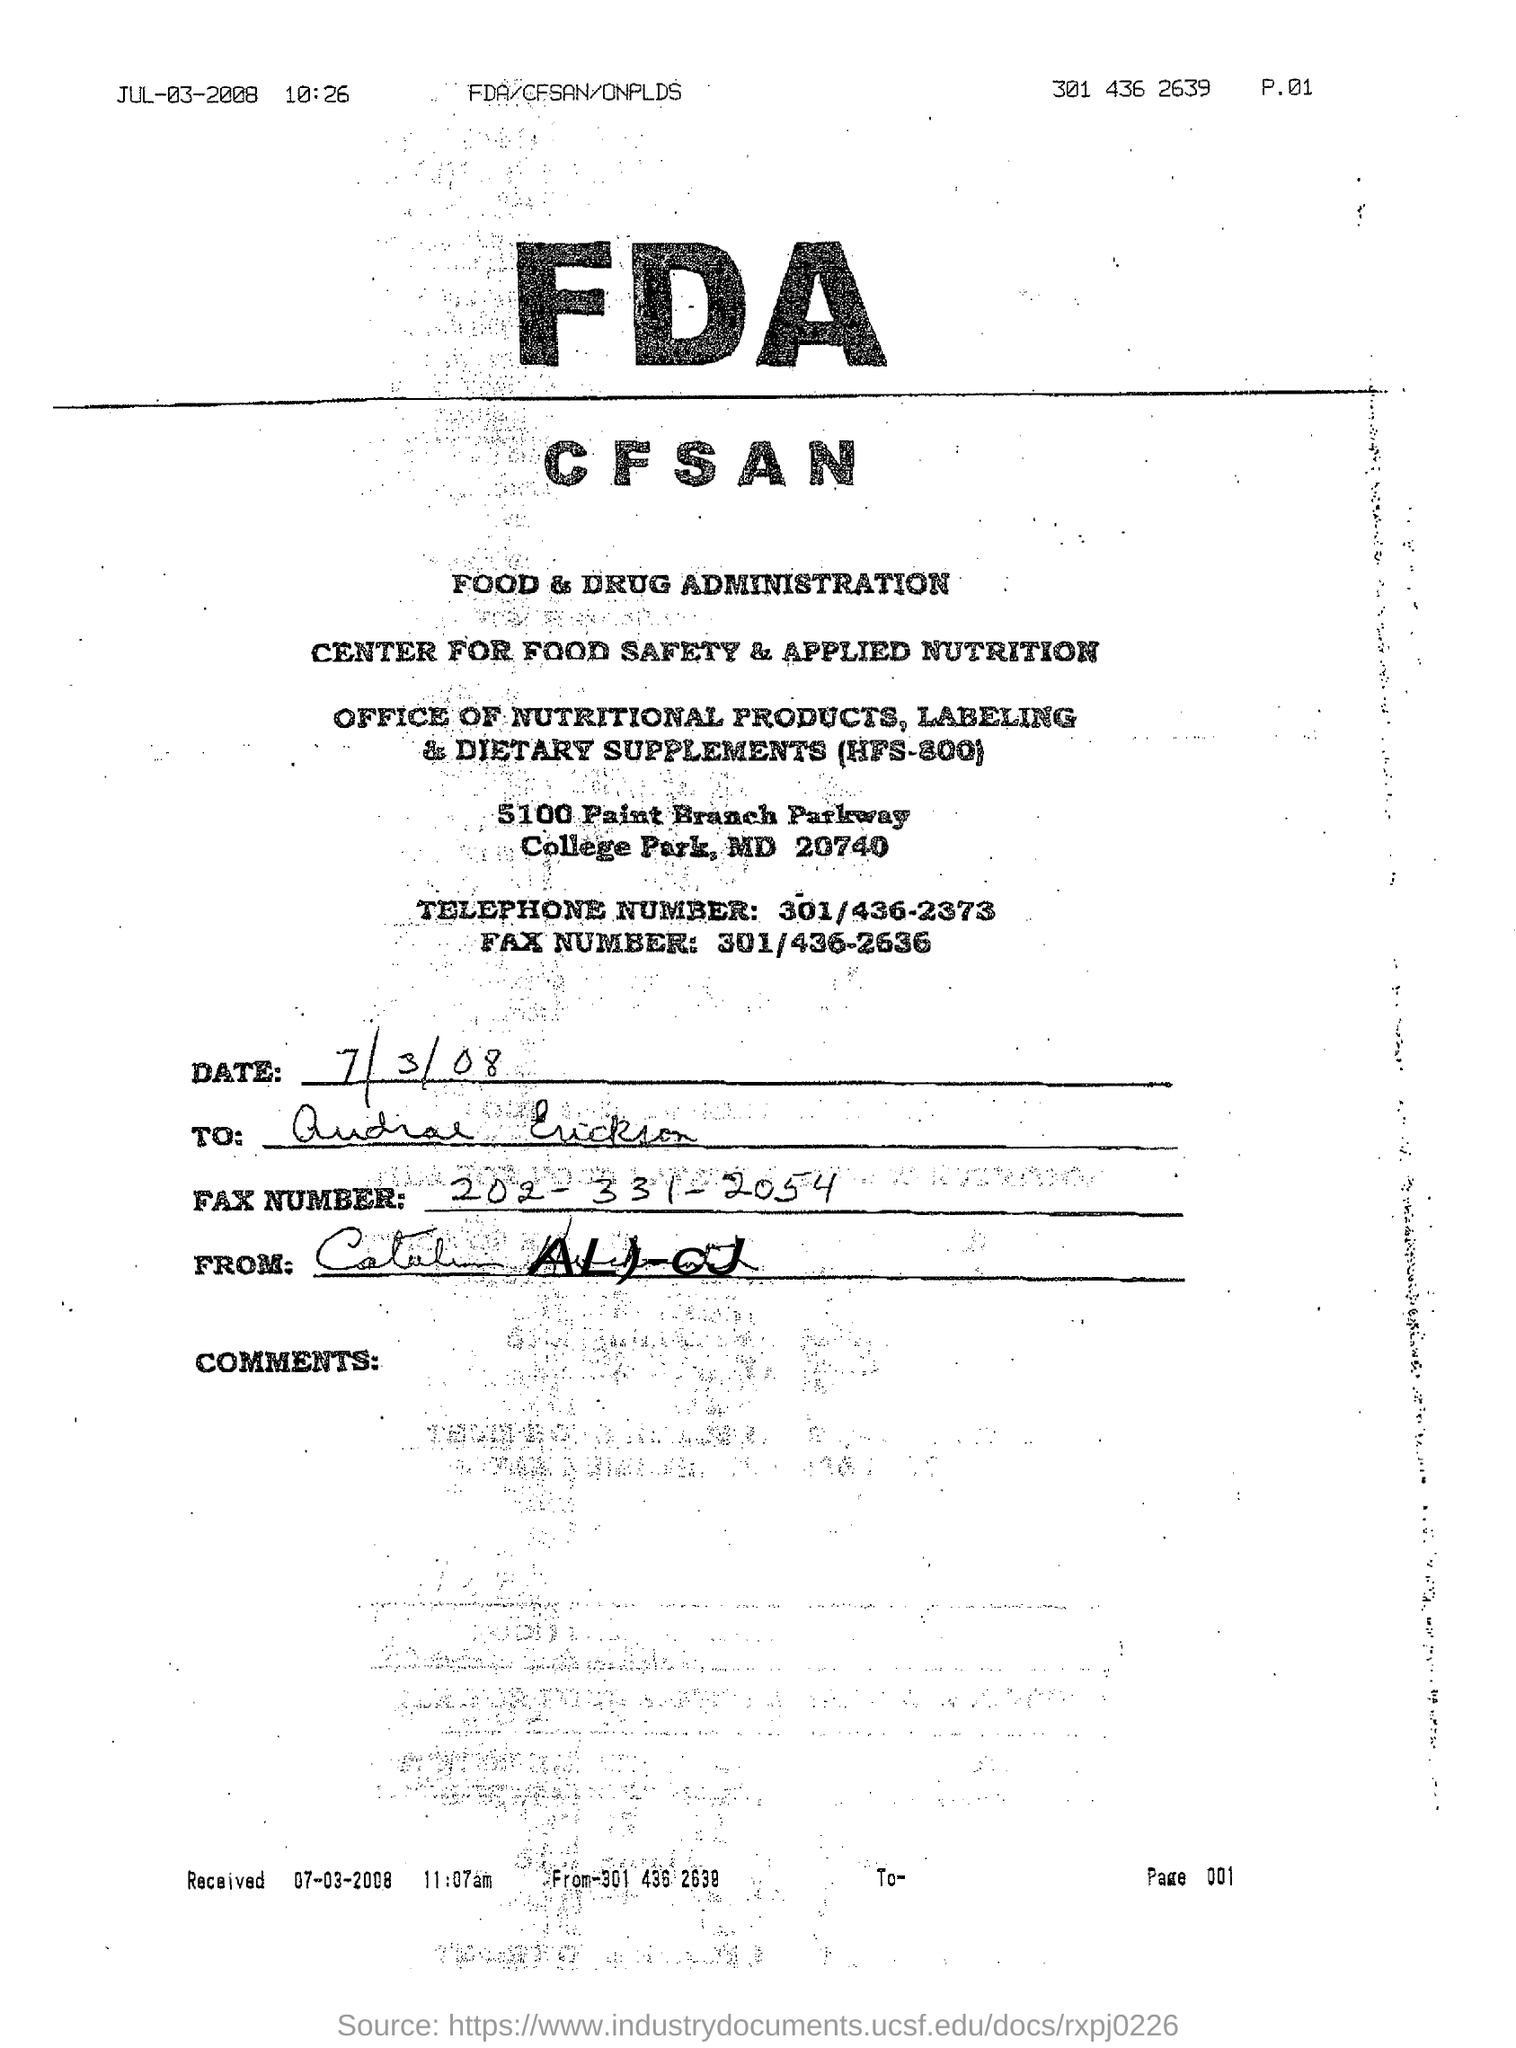What is the Telephone Number given?
Your response must be concise. 301/436-2373. What is the fulll form of FDA?
Your response must be concise. Food & Drug Administration. 